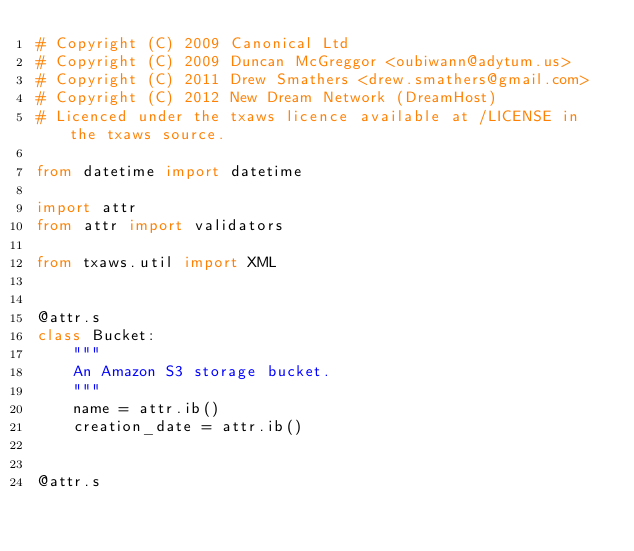Convert code to text. <code><loc_0><loc_0><loc_500><loc_500><_Python_># Copyright (C) 2009 Canonical Ltd
# Copyright (C) 2009 Duncan McGreggor <oubiwann@adytum.us>
# Copyright (C) 2011 Drew Smathers <drew.smathers@gmail.com>
# Copyright (C) 2012 New Dream Network (DreamHost)
# Licenced under the txaws licence available at /LICENSE in the txaws source.

from datetime import datetime

import attr
from attr import validators

from txaws.util import XML


@attr.s
class Bucket:
    """
    An Amazon S3 storage bucket.
    """
    name = attr.ib()
    creation_date = attr.ib()


@attr.s</code> 